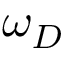Convert formula to latex. <formula><loc_0><loc_0><loc_500><loc_500>\omega _ { D }</formula> 